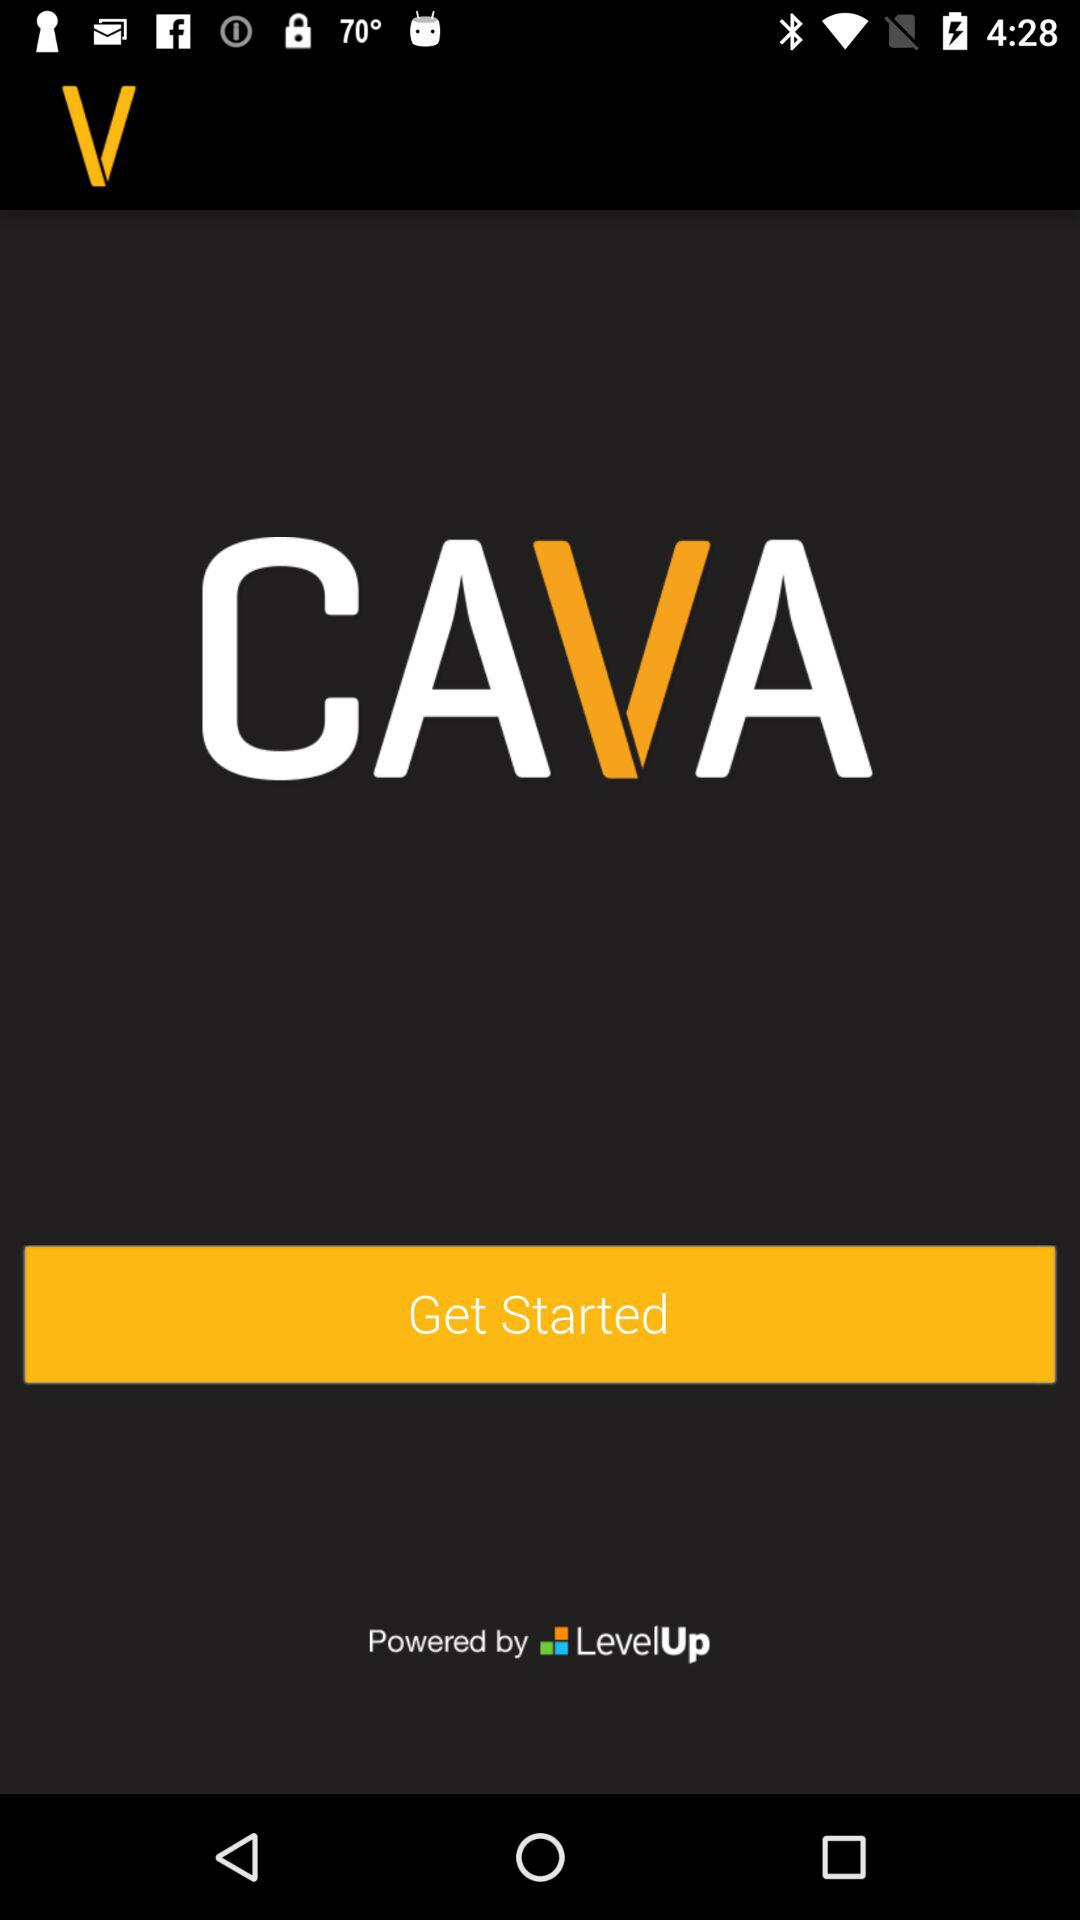Who developed the application?
When the provided information is insufficient, respond with <no answer>. <no answer> 